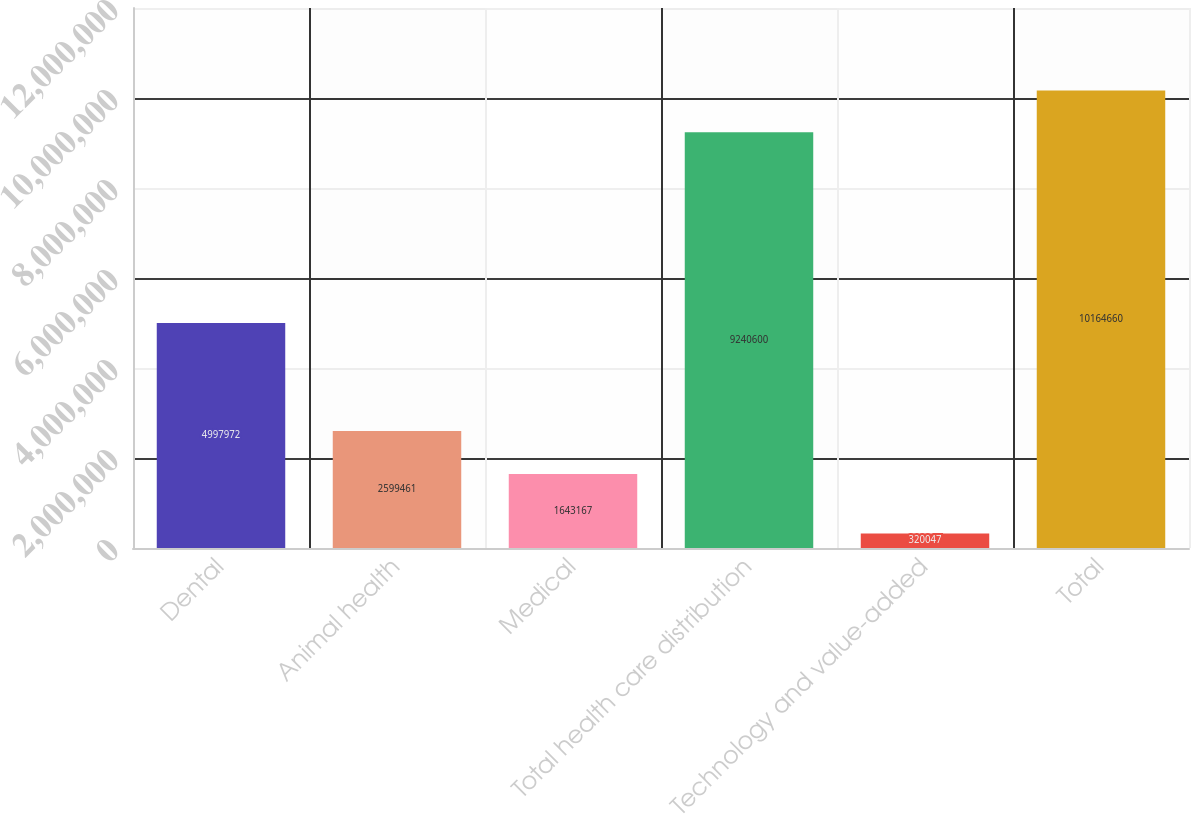<chart> <loc_0><loc_0><loc_500><loc_500><bar_chart><fcel>Dental<fcel>Animal health<fcel>Medical<fcel>Total health care distribution<fcel>Technology and value-added<fcel>Total<nl><fcel>4.99797e+06<fcel>2.59946e+06<fcel>1.64317e+06<fcel>9.2406e+06<fcel>320047<fcel>1.01647e+07<nl></chart> 